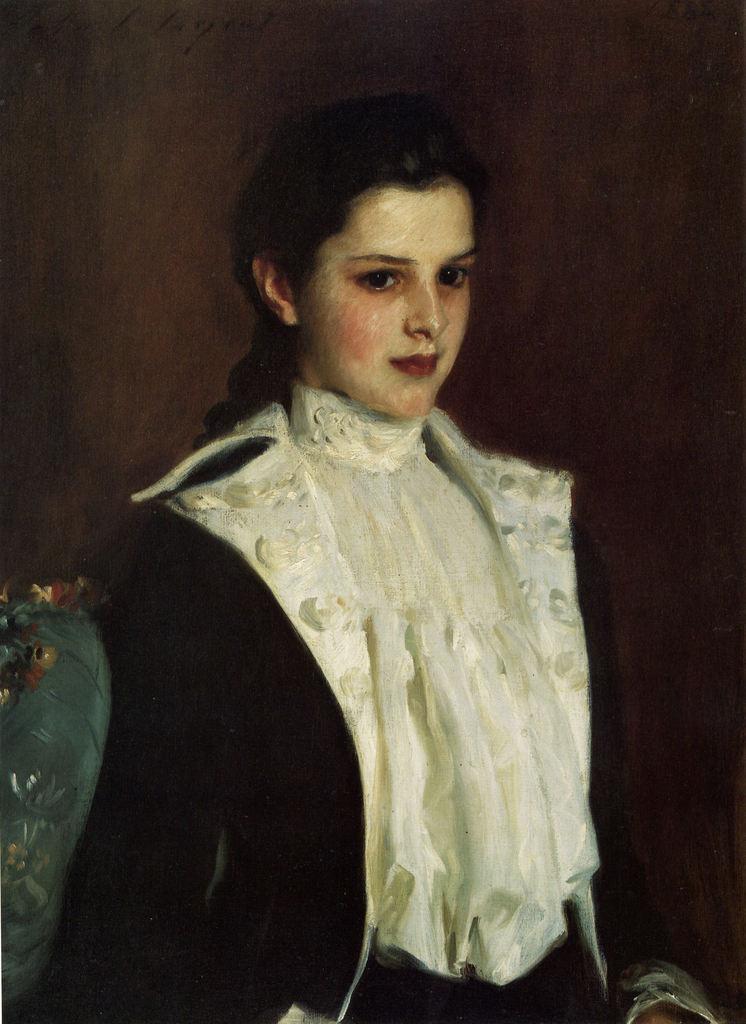How would you summarize this image in a sentence or two? A beautiful woman is standing, she wore white color dress and a black color coat. 